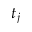<formula> <loc_0><loc_0><loc_500><loc_500>t _ { j }</formula> 